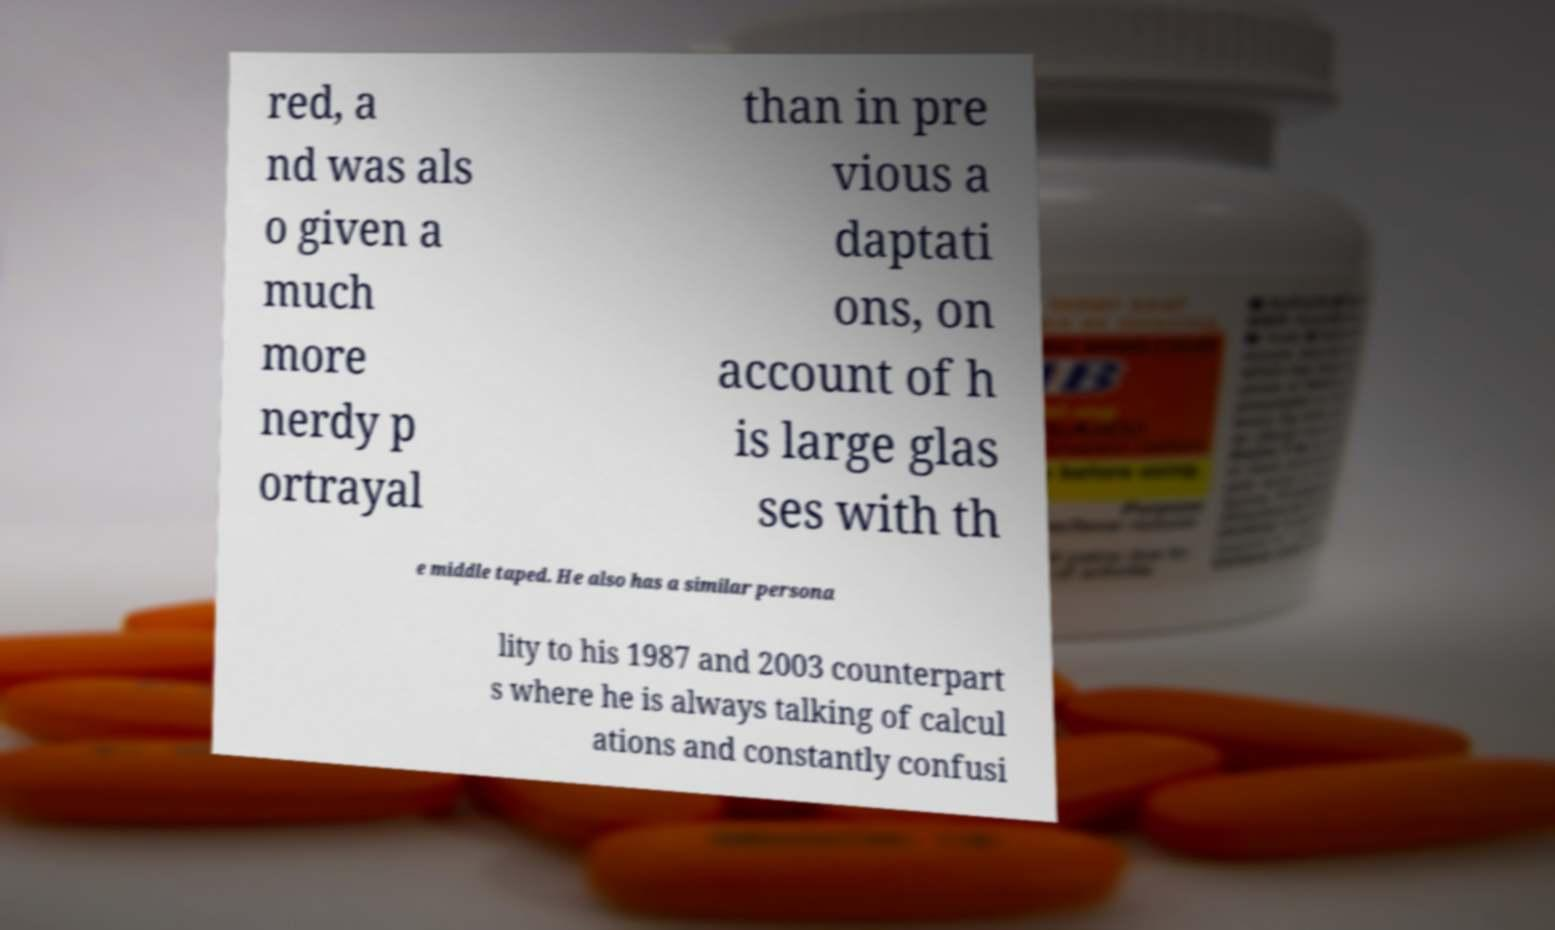There's text embedded in this image that I need extracted. Can you transcribe it verbatim? red, a nd was als o given a much more nerdy p ortrayal than in pre vious a daptati ons, on account of h is large glas ses with th e middle taped. He also has a similar persona lity to his 1987 and 2003 counterpart s where he is always talking of calcul ations and constantly confusi 